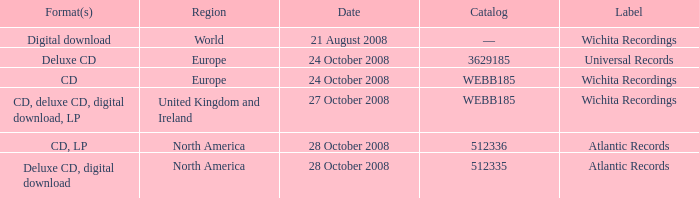What are the formats associated with the Atlantic Records label, catalog number 512336? CD, LP. 